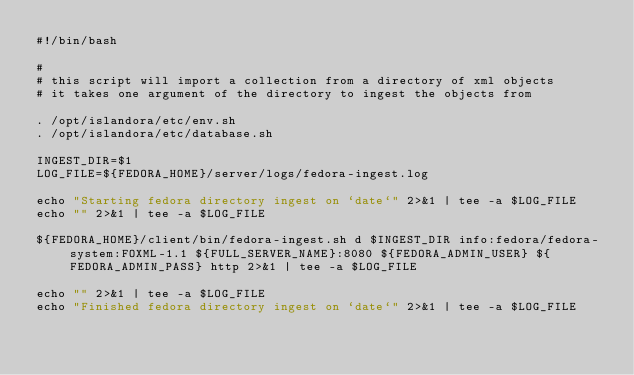Convert code to text. <code><loc_0><loc_0><loc_500><loc_500><_Bash_>#!/bin/bash

#
# this script will import a collection from a directory of xml objects
# it takes one argument of the directory to ingest the objects from

. /opt/islandora/etc/env.sh
. /opt/islandora/etc/database.sh

INGEST_DIR=$1
LOG_FILE=${FEDORA_HOME}/server/logs/fedora-ingest.log

echo "Starting fedora directory ingest on `date`" 2>&1 | tee -a $LOG_FILE
echo "" 2>&1 | tee -a $LOG_FILE

${FEDORA_HOME}/client/bin/fedora-ingest.sh d $INGEST_DIR info:fedora/fedora-system:FOXML-1.1 ${FULL_SERVER_NAME}:8080 ${FEDORA_ADMIN_USER} ${FEDORA_ADMIN_PASS} http 2>&1 | tee -a $LOG_FILE

echo "" 2>&1 | tee -a $LOG_FILE
echo "Finished fedora directory ingest on `date`" 2>&1 | tee -a $LOG_FILE
</code> 